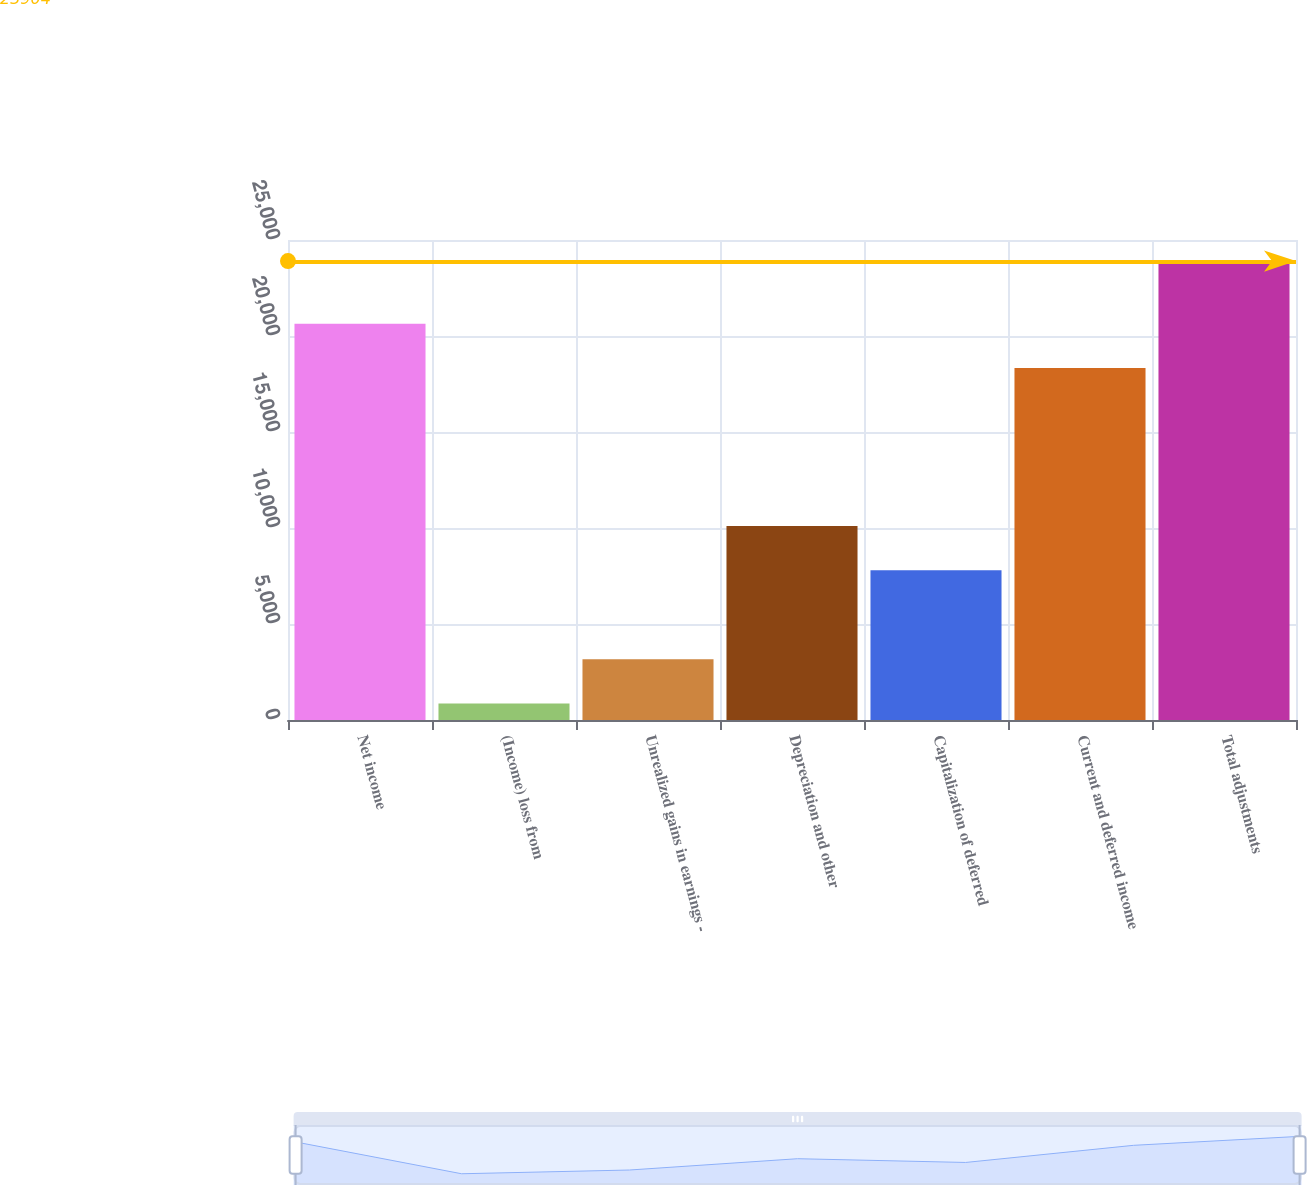<chart> <loc_0><loc_0><loc_500><loc_500><bar_chart><fcel>Net income<fcel>(Income) loss from<fcel>Unrealized gains in earnings -<fcel>Depreciation and other<fcel>Capitalization of deferred<fcel>Current and deferred income<fcel>Total adjustments<nl><fcel>20637.6<fcel>858<fcel>3162.6<fcel>10100.6<fcel>7796<fcel>18333<fcel>23904<nl></chart> 